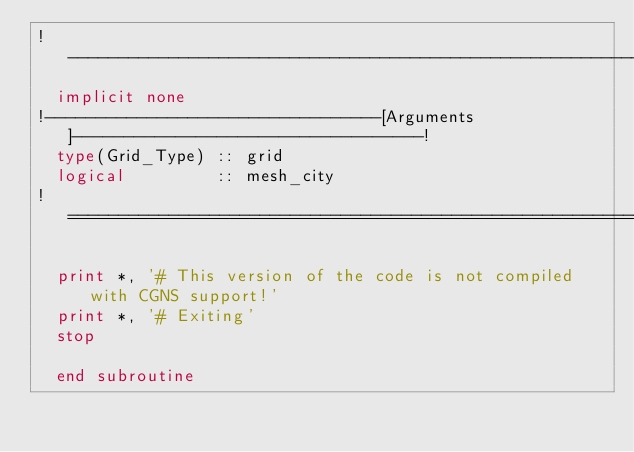Convert code to text. <code><loc_0><loc_0><loc_500><loc_500><_FORTRAN_>!------------------------------------------------------------------------------!
  implicit none
!---------------------------------[Arguments]----------------------------------!
  type(Grid_Type) :: grid
  logical         :: mesh_city
!==============================================================================!

  print *, '# This version of the code is not compiled with CGNS support!'
  print *, '# Exiting'
  stop

  end subroutine
</code> 